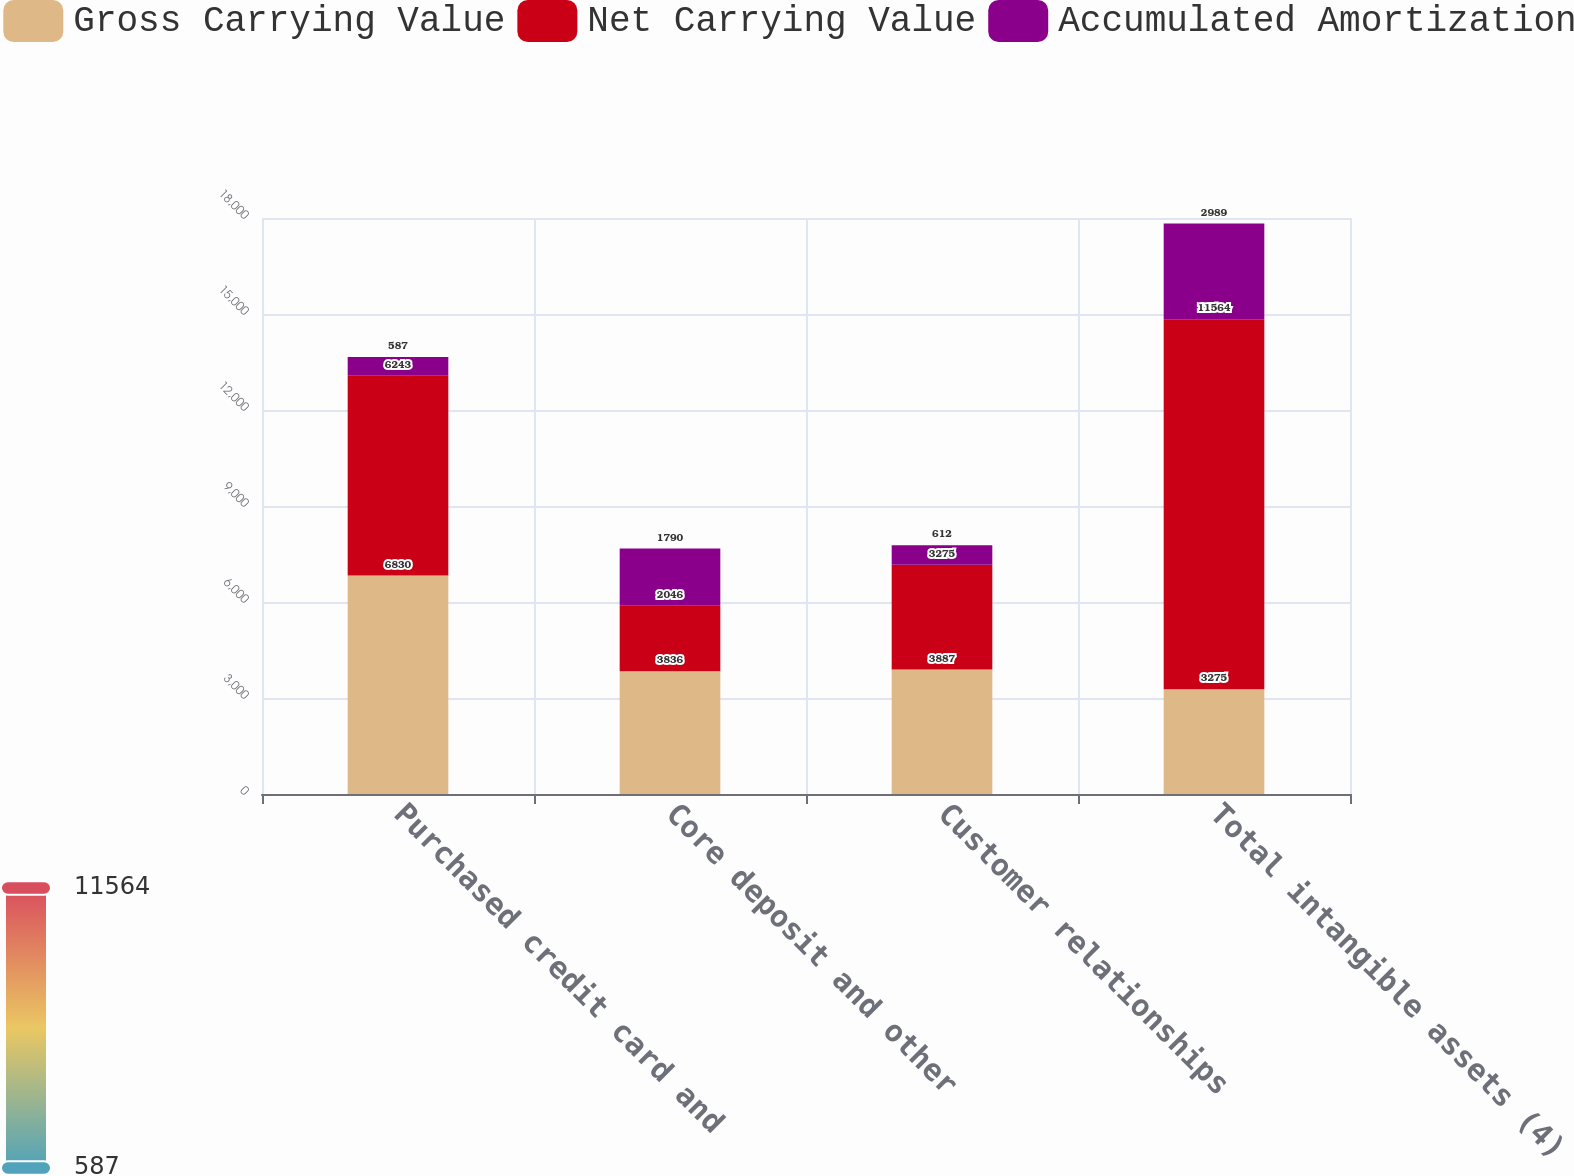<chart> <loc_0><loc_0><loc_500><loc_500><stacked_bar_chart><ecel><fcel>Purchased credit card and<fcel>Core deposit and other<fcel>Customer relationships<fcel>Total intangible assets (4)<nl><fcel>Gross Carrying Value<fcel>6830<fcel>3836<fcel>3887<fcel>3275<nl><fcel>Net Carrying Value<fcel>6243<fcel>2046<fcel>3275<fcel>11564<nl><fcel>Accumulated Amortization<fcel>587<fcel>1790<fcel>612<fcel>2989<nl></chart> 